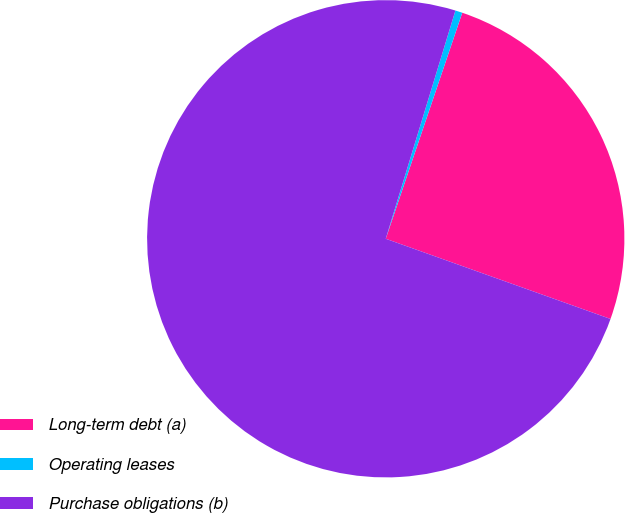Convert chart. <chart><loc_0><loc_0><loc_500><loc_500><pie_chart><fcel>Long-term debt (a)<fcel>Operating leases<fcel>Purchase obligations (b)<nl><fcel>25.26%<fcel>0.48%<fcel>74.26%<nl></chart> 